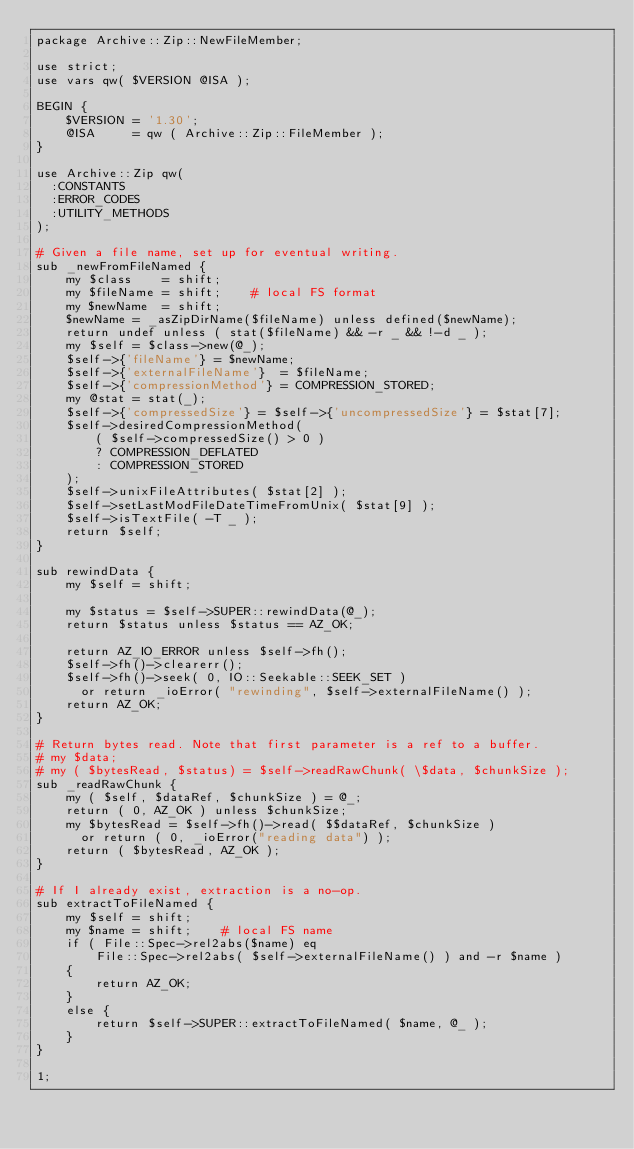<code> <loc_0><loc_0><loc_500><loc_500><_Perl_>package Archive::Zip::NewFileMember;

use strict;
use vars qw( $VERSION @ISA );

BEGIN {
    $VERSION = '1.30';
    @ISA     = qw ( Archive::Zip::FileMember );
}

use Archive::Zip qw(
  :CONSTANTS
  :ERROR_CODES
  :UTILITY_METHODS
);

# Given a file name, set up for eventual writing.
sub _newFromFileNamed {
    my $class    = shift;
    my $fileName = shift;    # local FS format
    my $newName  = shift;
    $newName = _asZipDirName($fileName) unless defined($newName);
    return undef unless ( stat($fileName) && -r _ && !-d _ );
    my $self = $class->new(@_);
    $self->{'fileName'} = $newName;
    $self->{'externalFileName'}  = $fileName;
    $self->{'compressionMethod'} = COMPRESSION_STORED;
    my @stat = stat(_);
    $self->{'compressedSize'} = $self->{'uncompressedSize'} = $stat[7];
    $self->desiredCompressionMethod(
        ( $self->compressedSize() > 0 )
        ? COMPRESSION_DEFLATED
        : COMPRESSION_STORED
    );
    $self->unixFileAttributes( $stat[2] );
    $self->setLastModFileDateTimeFromUnix( $stat[9] );
    $self->isTextFile( -T _ );
    return $self;
}

sub rewindData {
    my $self = shift;

    my $status = $self->SUPER::rewindData(@_);
    return $status unless $status == AZ_OK;

    return AZ_IO_ERROR unless $self->fh();
    $self->fh()->clearerr();
    $self->fh()->seek( 0, IO::Seekable::SEEK_SET )
      or return _ioError( "rewinding", $self->externalFileName() );
    return AZ_OK;
}

# Return bytes read. Note that first parameter is a ref to a buffer.
# my $data;
# my ( $bytesRead, $status) = $self->readRawChunk( \$data, $chunkSize );
sub _readRawChunk {
    my ( $self, $dataRef, $chunkSize ) = @_;
    return ( 0, AZ_OK ) unless $chunkSize;
    my $bytesRead = $self->fh()->read( $$dataRef, $chunkSize )
      or return ( 0, _ioError("reading data") );
    return ( $bytesRead, AZ_OK );
}

# If I already exist, extraction is a no-op.
sub extractToFileNamed {
    my $self = shift;
    my $name = shift;    # local FS name
    if ( File::Spec->rel2abs($name) eq
        File::Spec->rel2abs( $self->externalFileName() ) and -r $name )
    {
        return AZ_OK;
    }
    else {
        return $self->SUPER::extractToFileNamed( $name, @_ );
    }
}

1;
</code> 